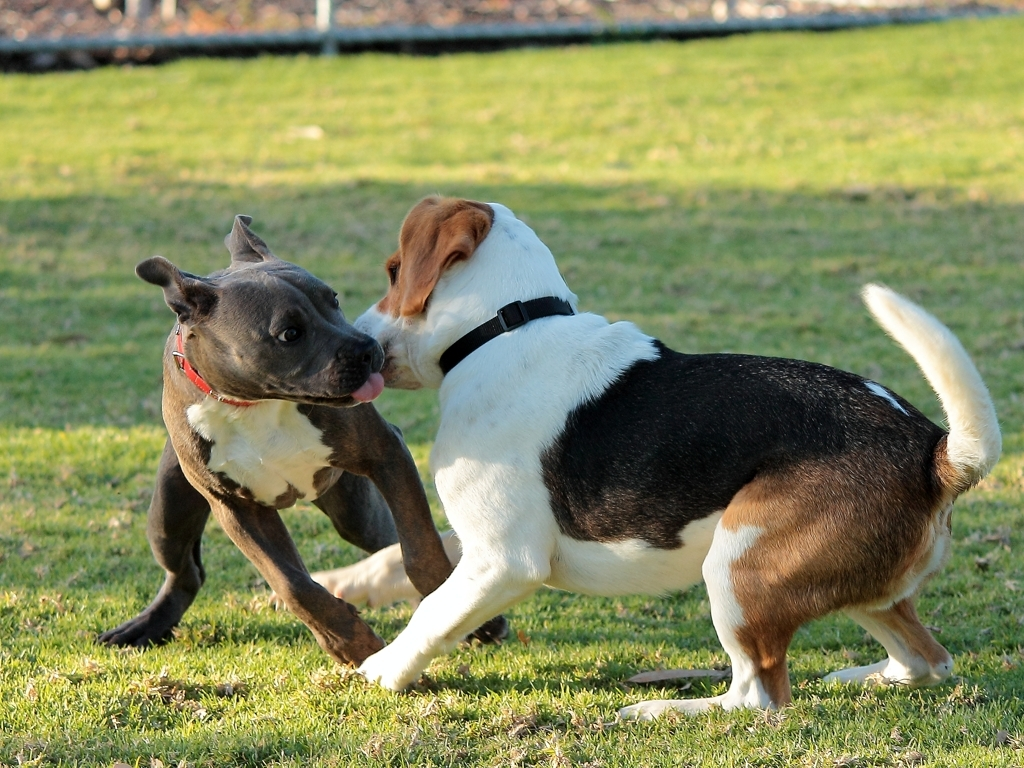What breeds of dogs might these be, based on their appearance? Based on their physical characteristics, the dog on the left appears to be a type of pit bull or pit bull mix, noted by its stocky build, broad head, and smooth coat. The dog on the right resembles a beagle or a beagle mix, as suggested by its tri-color coat, long ears, and medium build. Identifying breeds by appearance alone can be tricky and might not be fully accurate. 